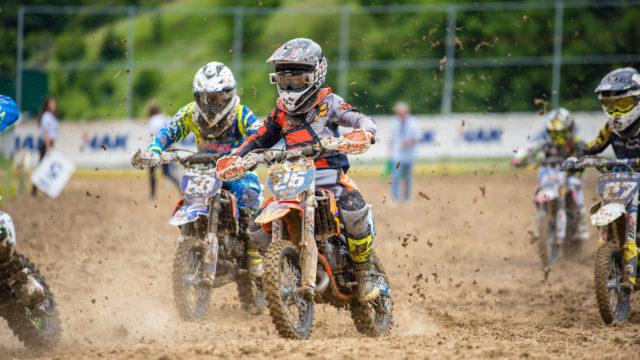How many motorbikes would there be in the image after one more motorbike has been added in the image? 5 